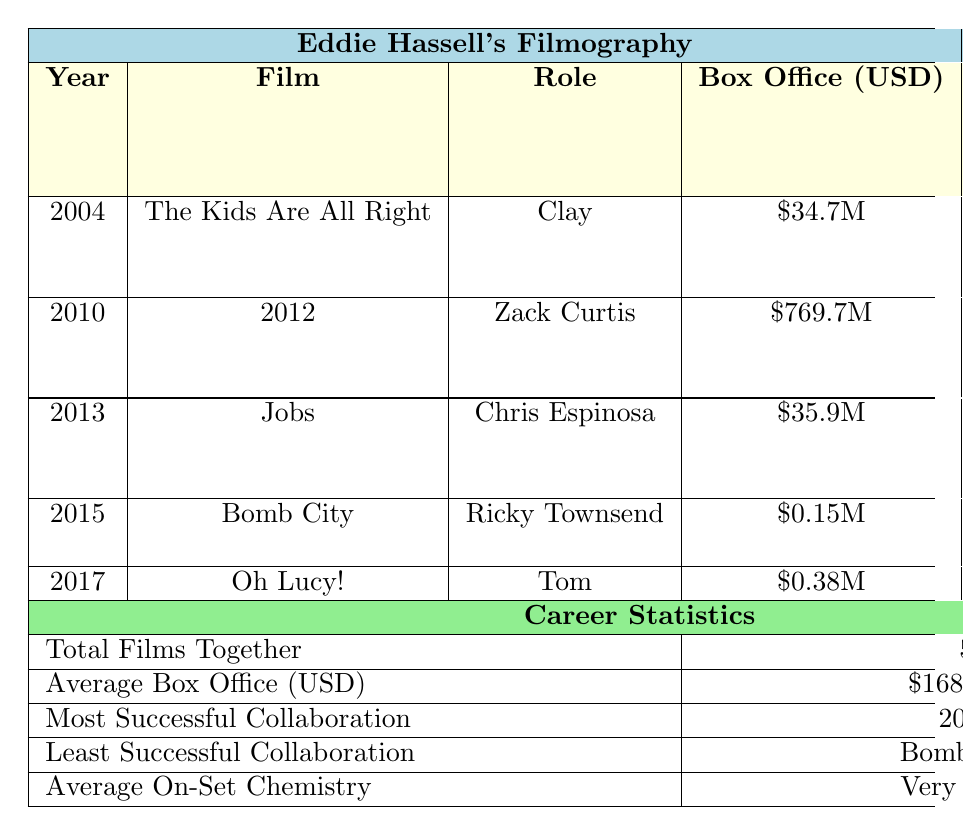What was the box office performance of the film "2012"? The table lists the box office performance for "2012" as \$769.7 million.
Answer: \$769.7 million Which film had the least box office performance? The table indicates that "Bomb City" had the least box office performance, reported as \$0.15 million.
Answer: Bomb City How many scenes did we have together in the film "Oh Lucy!"? The table shows that there were 6 scenes together in "Oh Lucy!".
Answer: 6 scenes What is the average box office performance of all films Eddie Hassell appeared in? To find the average, sum all box office values: 34.7 + 769.7 + 35.9 + 0.15 + 0.38 = 840.83 million, then divide by 5 films, yielding 840.83 / 5 = \$168.17 million.
Answer: \$168.17 million True or False: Our collaboration in "Jobs" had excellent on-set chemistry. The table specifies that the on-set chemistry in "Jobs" was only average, not excellent.
Answer: False How many films did we collaborate on that made over \$30 million at the box office? From the table, "The Kids Are All Right" (\$34.7M), "2012" (\$769.7M), and "Jobs" (\$35.9M) are the ones over \$30 million. Counting these gives us 3 films.
Answer: 3 films Which film had the most scenes together? According to the table, the film "2012" had the most scenes together, totaling 12 scenes.
Answer: 2012 Did we have better on-set chemistry in "The Kids Are All Right" or "Oh Lucy!"? "Oh Lucy!" had excellent on-set chemistry, while "The Kids Are All Right" had excellent as well, making them equal. Both are excellent, but it's a comparison of style.
Answer: Equal What is the total number of films we worked on together? The table clearly states that we collaborated in a total of 5 films.
Answer: 5 films What was the average on-set chemistry rating in our collaborations? The average on-set chemistry rating given in the table is described as "Very Good".
Answer: Very Good 